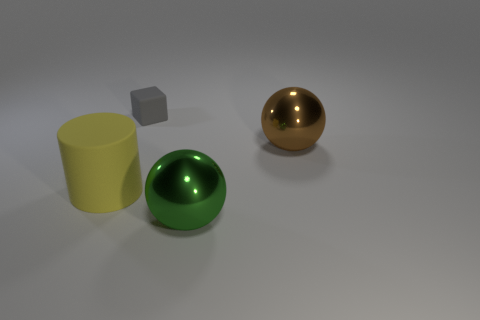Add 1 tiny cyan metallic cylinders. How many objects exist? 5 Subtract all green spheres. How many spheres are left? 1 Subtract 1 cylinders. How many cylinders are left? 0 Subtract all purple cylinders. Subtract all blue balls. How many cylinders are left? 1 Subtract all rubber blocks. Subtract all cubes. How many objects are left? 2 Add 3 yellow cylinders. How many yellow cylinders are left? 4 Add 2 small balls. How many small balls exist? 2 Subtract 1 brown balls. How many objects are left? 3 Subtract all blocks. How many objects are left? 3 